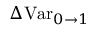<formula> <loc_0><loc_0><loc_500><loc_500>\Delta V a r _ { 0 \rightarrow 1 }</formula> 